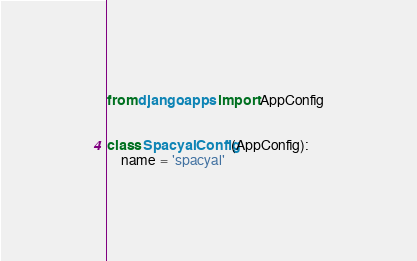<code> <loc_0><loc_0><loc_500><loc_500><_Python_>from django.apps import AppConfig


class SpacyalConfig(AppConfig):
    name = 'spacyal'
</code> 